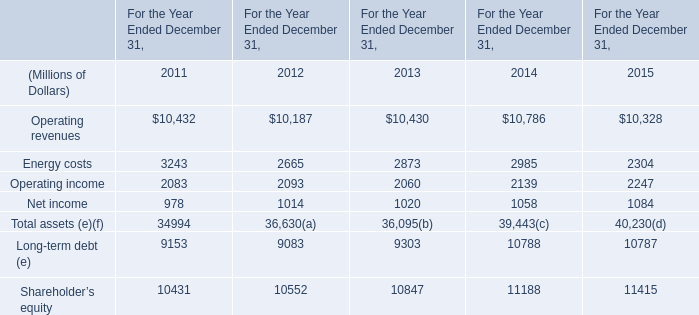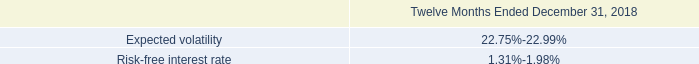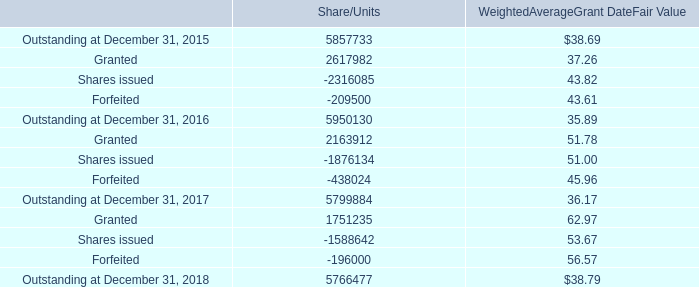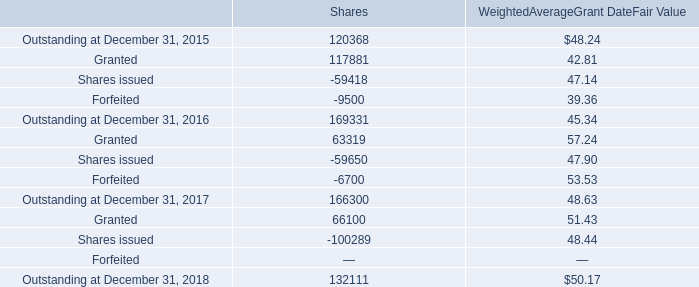What's the average of Energy costs of For the Year Ended December 31, 2012, and Shares issued of Shares ? 
Computations: ((2665.0 + 59418.0) / 2)
Answer: 31041.5. 